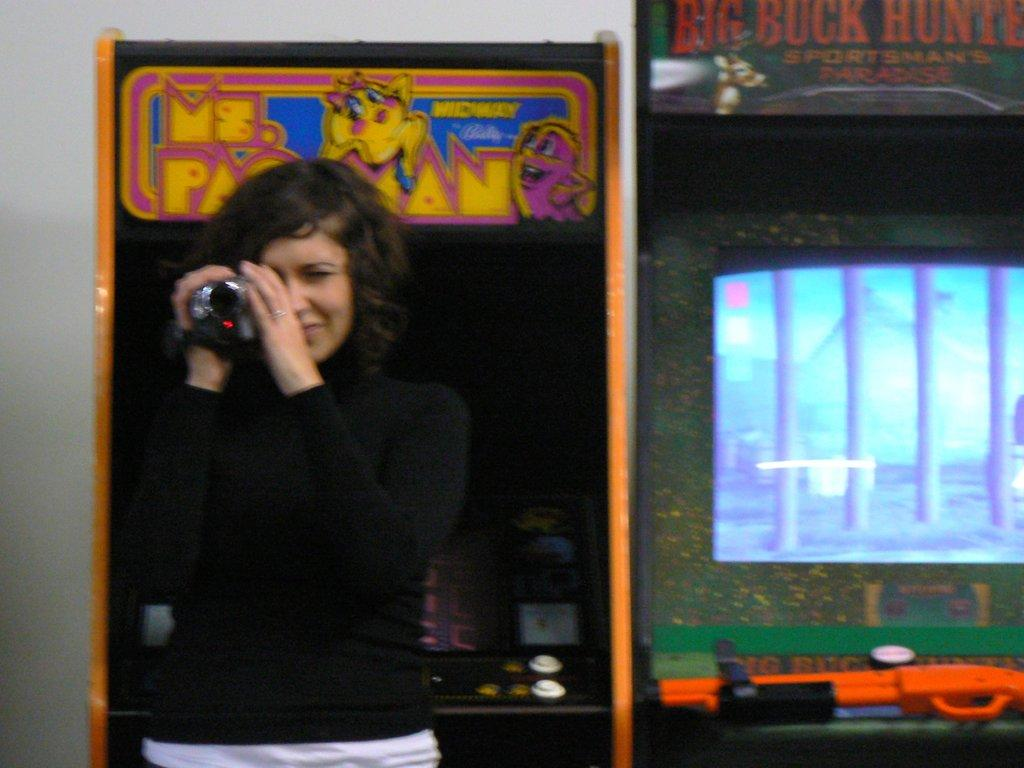Who is the main subject in the image? There is a lady in the image. What is the lady holding in the image? The lady is holding a camera. What can be seen in the background of the image? There are displays of video games and a wall in the background. What type of ice can be seen on the plate in the image? There is no ice or plate present in the image. 